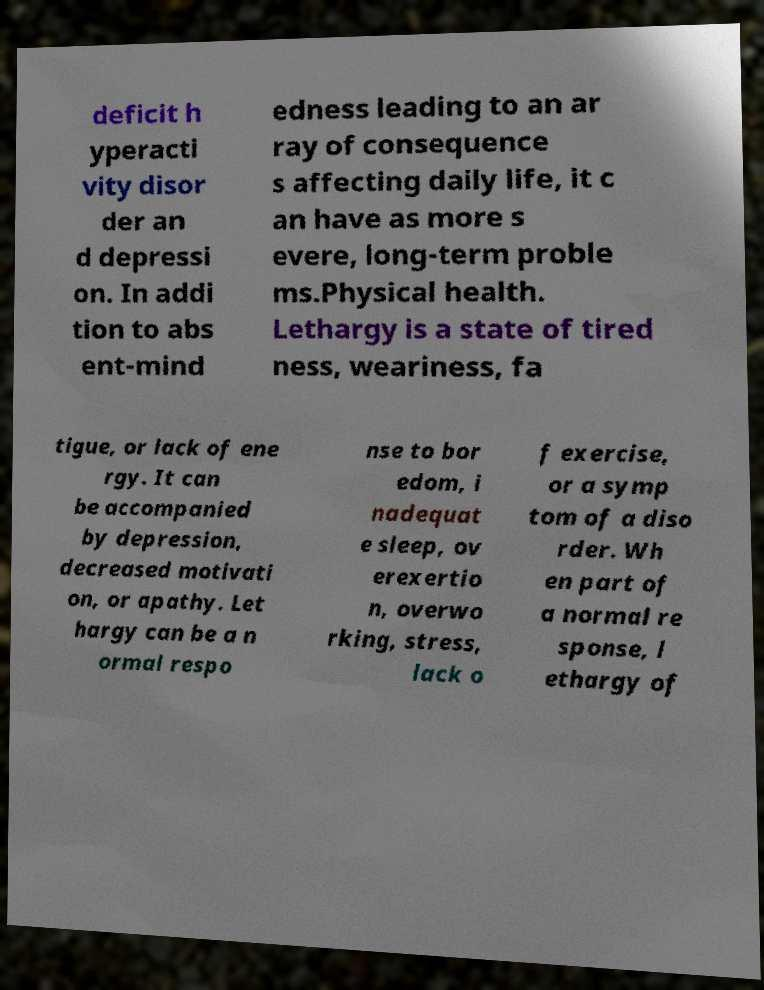I need the written content from this picture converted into text. Can you do that? deficit h yperacti vity disor der an d depressi on. In addi tion to abs ent-mind edness leading to an ar ray of consequence s affecting daily life, it c an have as more s evere, long-term proble ms.Physical health. Lethargy is a state of tired ness, weariness, fa tigue, or lack of ene rgy. It can be accompanied by depression, decreased motivati on, or apathy. Let hargy can be a n ormal respo nse to bor edom, i nadequat e sleep, ov erexertio n, overwo rking, stress, lack o f exercise, or a symp tom of a diso rder. Wh en part of a normal re sponse, l ethargy of 